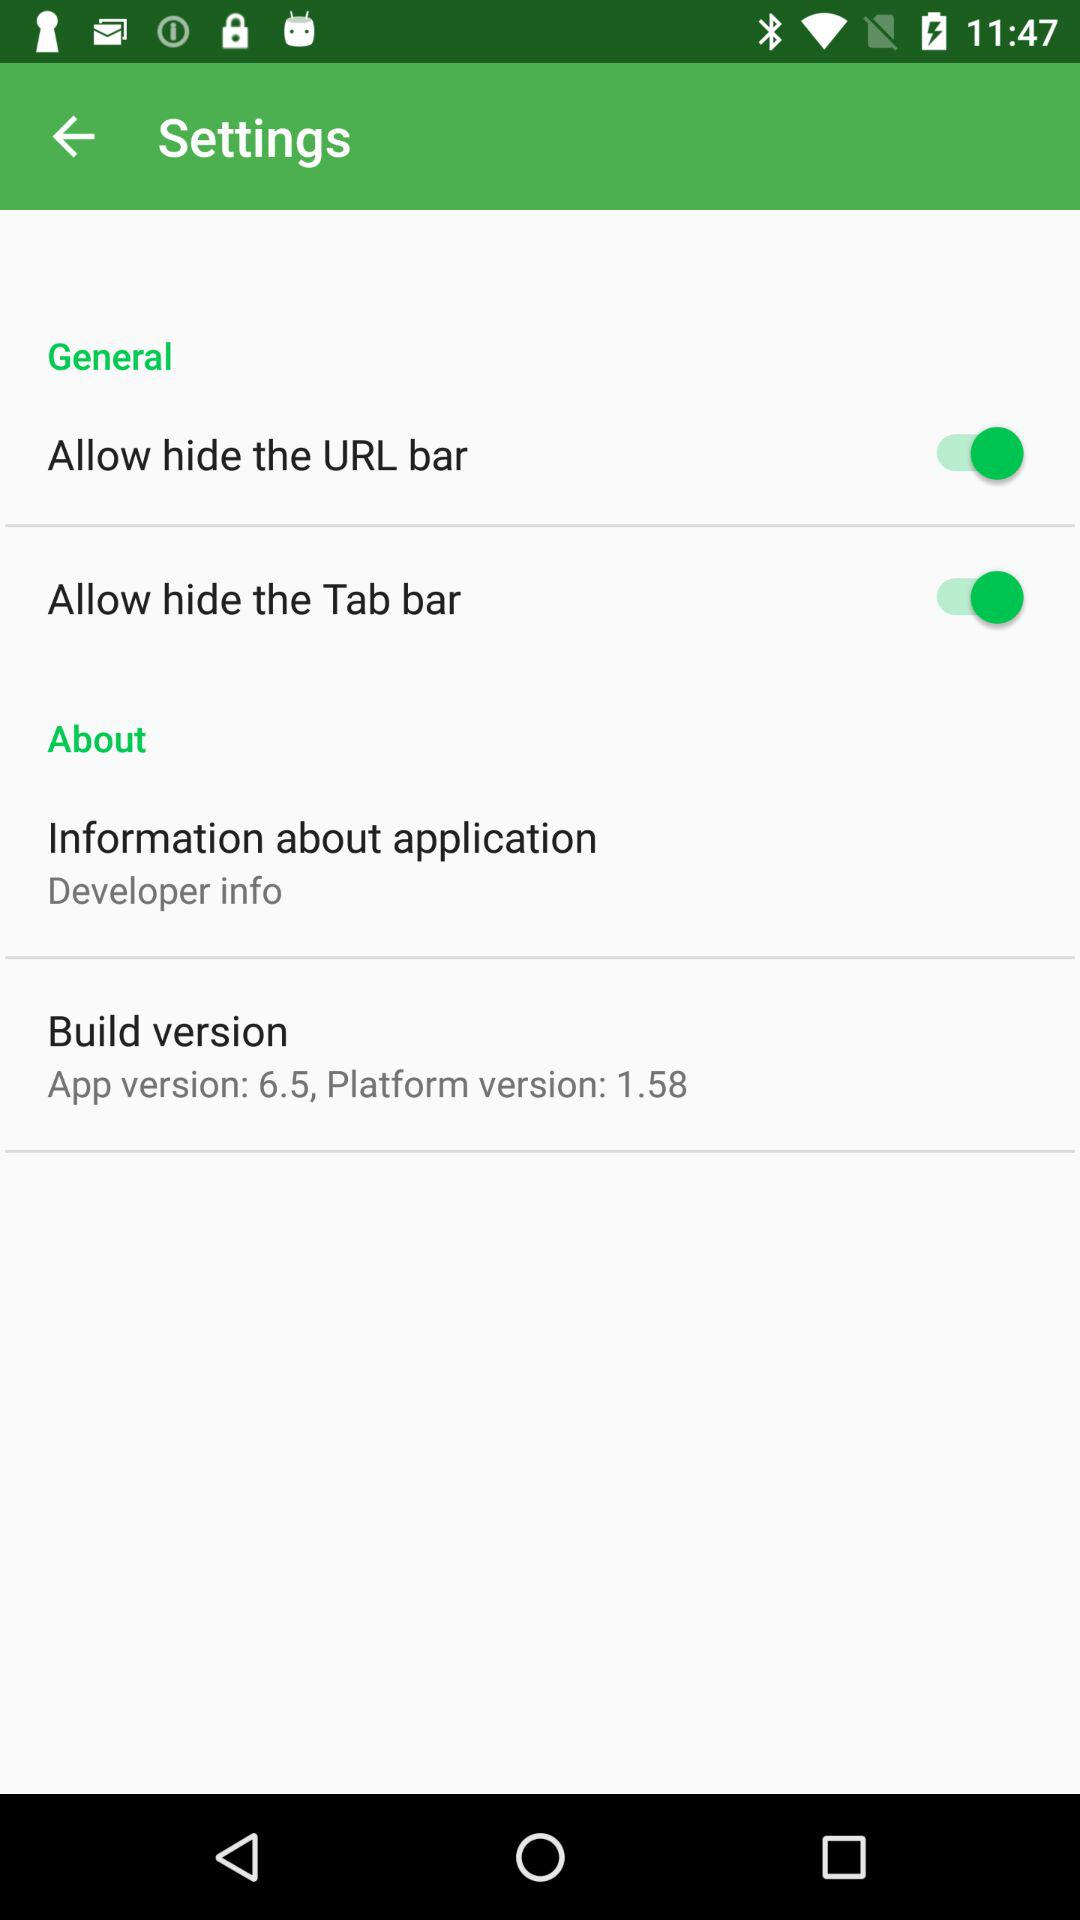What is the current platform version? The current platform version is 1.58. 